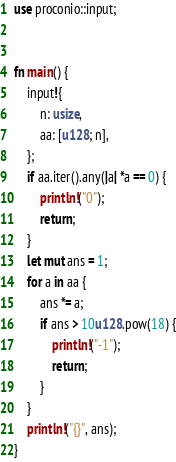Convert code to text. <code><loc_0><loc_0><loc_500><loc_500><_Rust_>use proconio::input;


fn main() {
    input!{
        n: usize,
        aa: [u128; n],
    };
    if aa.iter().any(|a| *a == 0) {
        println!("0");
        return;
    }
    let mut ans = 1;
    for a in aa {
        ans *= a;
        if ans > 10u128.pow(18) {
            println!("-1");
            return;
        }
    }
    println!("{}", ans);
}
</code> 